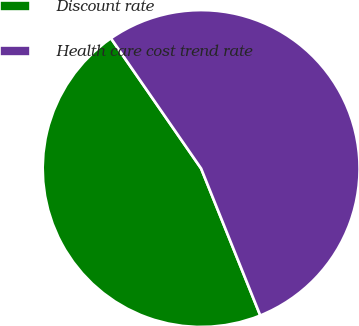Convert chart to OTSL. <chart><loc_0><loc_0><loc_500><loc_500><pie_chart><fcel>Discount rate<fcel>Health care cost trend rate<nl><fcel>46.45%<fcel>53.55%<nl></chart> 